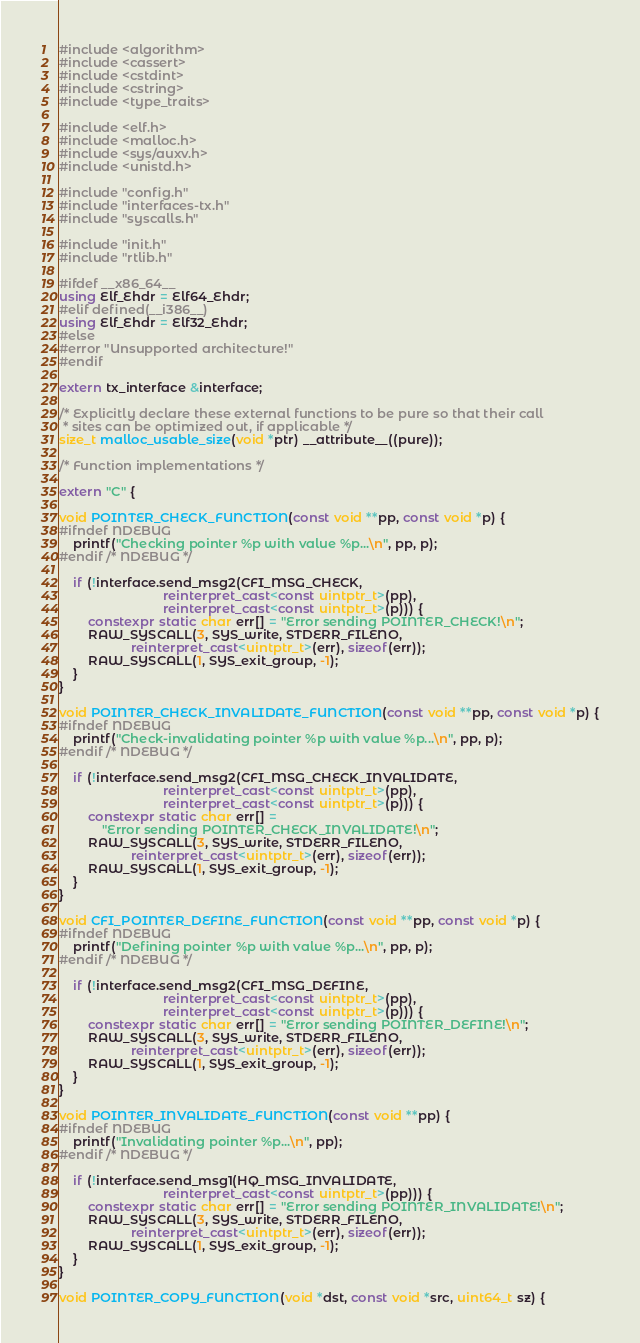Convert code to text. <code><loc_0><loc_0><loc_500><loc_500><_C++_>#include <algorithm>
#include <cassert>
#include <cstdint>
#include <cstring>
#include <type_traits>

#include <elf.h>
#include <malloc.h>
#include <sys/auxv.h>
#include <unistd.h>

#include "config.h"
#include "interfaces-tx.h"
#include "syscalls.h"

#include "init.h"
#include "rtlib.h"

#ifdef __x86_64__
using Elf_Ehdr = Elf64_Ehdr;
#elif defined(__i386__)
using Elf_Ehdr = Elf32_Ehdr;
#else
#error "Unsupported architecture!"
#endif

extern tx_interface &interface;

/* Explicitly declare these external functions to be pure so that their call
 * sites can be optimized out, if applicable */
size_t malloc_usable_size(void *ptr) __attribute__((pure));

/* Function implementations */

extern "C" {

void POINTER_CHECK_FUNCTION(const void **pp, const void *p) {
#ifndef NDEBUG
    printf("Checking pointer %p with value %p...\n", pp, p);
#endif /* NDEBUG */

    if (!interface.send_msg2(CFI_MSG_CHECK,
                             reinterpret_cast<const uintptr_t>(pp),
                             reinterpret_cast<const uintptr_t>(p))) {
        constexpr static char err[] = "Error sending POINTER_CHECK!\n";
        RAW_SYSCALL(3, SYS_write, STDERR_FILENO,
                    reinterpret_cast<uintptr_t>(err), sizeof(err));
        RAW_SYSCALL(1, SYS_exit_group, -1);
    }
}

void POINTER_CHECK_INVALIDATE_FUNCTION(const void **pp, const void *p) {
#ifndef NDEBUG
    printf("Check-invalidating pointer %p with value %p...\n", pp, p);
#endif /* NDEBUG */

    if (!interface.send_msg2(CFI_MSG_CHECK_INVALIDATE,
                             reinterpret_cast<const uintptr_t>(pp),
                             reinterpret_cast<const uintptr_t>(p))) {
        constexpr static char err[] =
            "Error sending POINTER_CHECK_INVALIDATE!\n";
        RAW_SYSCALL(3, SYS_write, STDERR_FILENO,
                    reinterpret_cast<uintptr_t>(err), sizeof(err));
        RAW_SYSCALL(1, SYS_exit_group, -1);
    }
}

void CFI_POINTER_DEFINE_FUNCTION(const void **pp, const void *p) {
#ifndef NDEBUG
    printf("Defining pointer %p with value %p...\n", pp, p);
#endif /* NDEBUG */

    if (!interface.send_msg2(CFI_MSG_DEFINE,
                             reinterpret_cast<const uintptr_t>(pp),
                             reinterpret_cast<const uintptr_t>(p))) {
        constexpr static char err[] = "Error sending POINTER_DEFINE!\n";
        RAW_SYSCALL(3, SYS_write, STDERR_FILENO,
                    reinterpret_cast<uintptr_t>(err), sizeof(err));
        RAW_SYSCALL(1, SYS_exit_group, -1);
    }
}

void POINTER_INVALIDATE_FUNCTION(const void **pp) {
#ifndef NDEBUG
    printf("Invalidating pointer %p...\n", pp);
#endif /* NDEBUG */

    if (!interface.send_msg1(HQ_MSG_INVALIDATE,
                             reinterpret_cast<const uintptr_t>(pp))) {
        constexpr static char err[] = "Error sending POINTER_INVALIDATE!\n";
        RAW_SYSCALL(3, SYS_write, STDERR_FILENO,
                    reinterpret_cast<uintptr_t>(err), sizeof(err));
        RAW_SYSCALL(1, SYS_exit_group, -1);
    }
}

void POINTER_COPY_FUNCTION(void *dst, const void *src, uint64_t sz) {</code> 